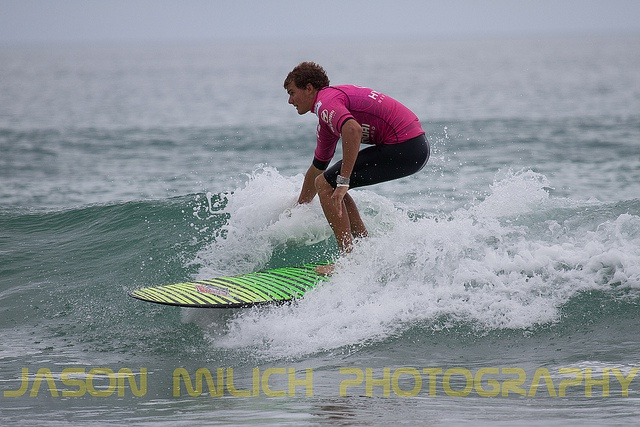Describe the objects in this image and their specific colors. I can see people in darkgray, black, maroon, and purple tones and surfboard in darkgray, gray, khaki, and lightgreen tones in this image. 